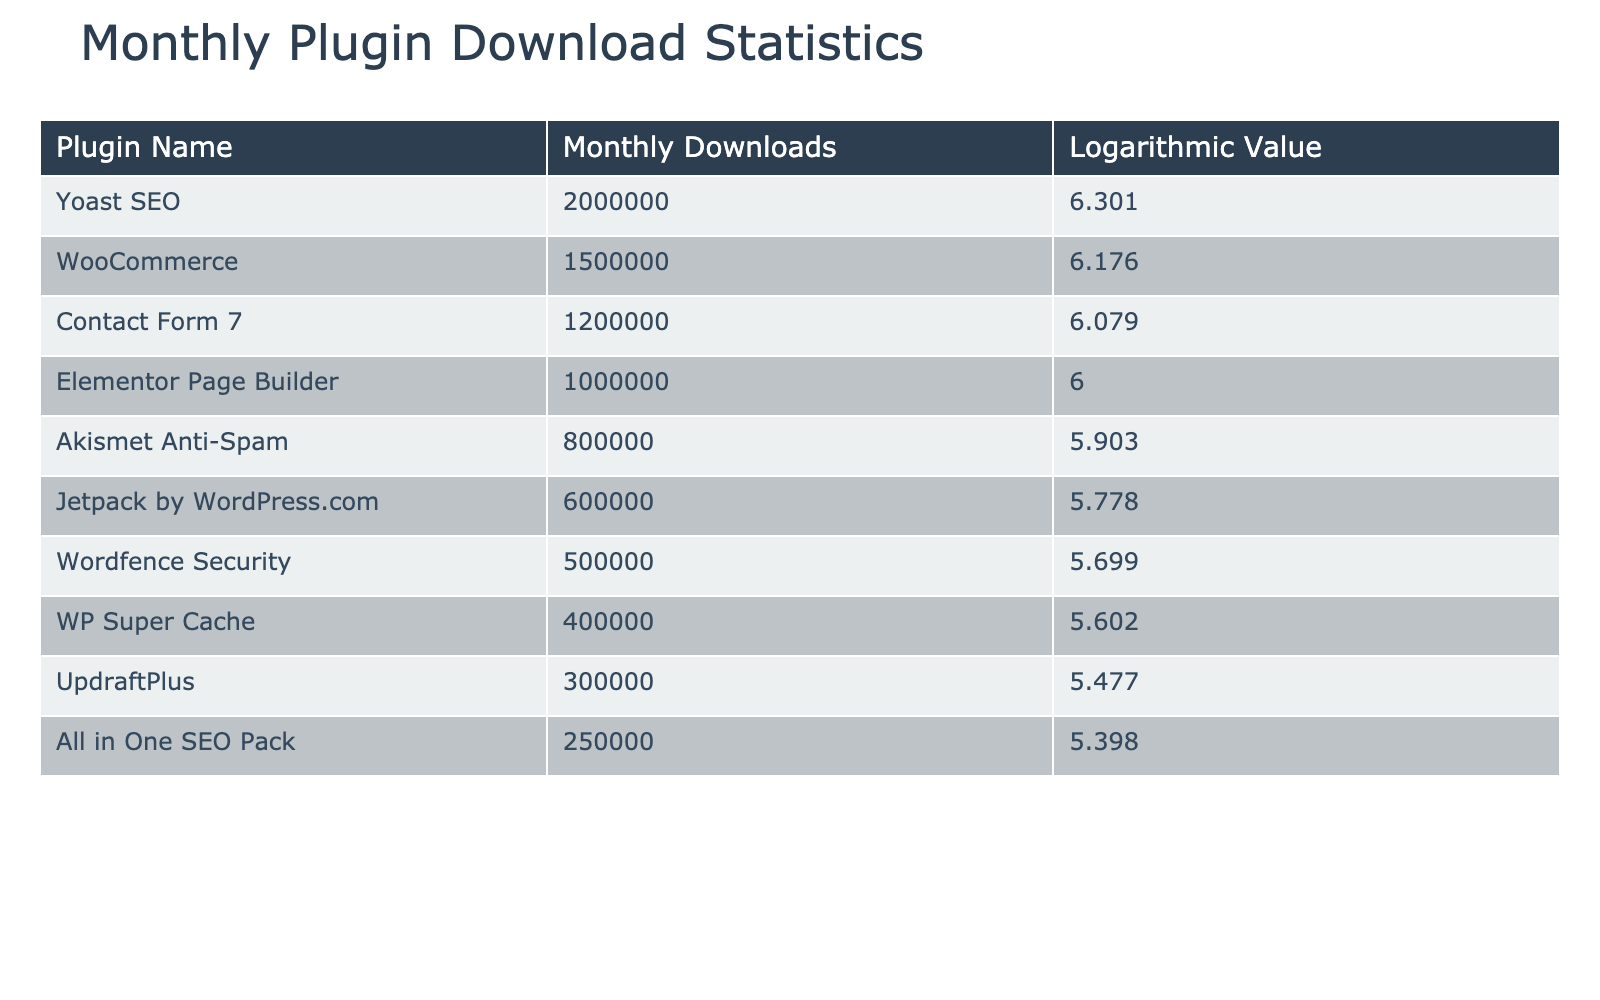What is the plugin with the highest number of monthly downloads? By examining the "Monthly Downloads" column, we can see that "Yoast SEO" has the highest value of 2,000,000.
Answer: Yoast SEO What is the logarithmic value associated with WooCommerce? Looking directly under the "Logarithmic Value" column for "WooCommerce," the value is 6.176.
Answer: 6.176 Is Elementor Page Builder more popular than Jetpack by WordPress.com in terms of monthly downloads? Checking the "Monthly Downloads" column, Elementor has 1,000,000 downloads while Jetpack has 600,000, indicating Elementor is more popular.
Answer: Yes What is the total number of monthly downloads for the top three plugins? The top three plugins are "Yoast SEO" (2,000,000), "WooCommerce" (1,500,000), and "Contact Form 7" (1,200,000). Adding these gives 2,000,000 + 1,500,000 + 1,200,000 = 4,700,000.
Answer: 4,700,000 What is the difference in logarithmic values between Akismet Anti-Spam and WP Super Cache? The logarithmic value for Akismet is 5.903 and for WP Super Cache, it is 5.602. The difference is 5.903 - 5.602 = 0.301.
Answer: 0.301 Which plugin has the lowest monthly downloads, and what is that number? In the "Monthly Downloads" column, "WP Super Cache" has the lowest number of downloads at 400,000.
Answer: WP Super Cache, 400,000 Is the logarithmic value of UpdraftPlus greater than that of All in One SEO Pack? The logarithmic value for UpdraftPlus is 5.477 and for All in One SEO Pack, it is 5.398. Since 5.477 is greater than 5.398, the statement is true.
Answer: Yes What is the average number of monthly downloads for the five least downloaded plugins? The five least downloaded plugins are Wordfence Security (500,000), WP Super Cache (400,000), UpdraftPlus (300,000), All in One SEO Pack (250,000), and Jetpack by WordPress.com (600,000). Their total is 500,000 + 400,000 + 300,000 + 250,000 + 600,000 = 2,050,000. The average is 2,050,000 / 5 = 410,000.
Answer: 410,000 What percentage of total downloads does Contact Form 7 contribute? First, calculate the total downloads: 2,000,000 + 1,500,000 + 1,200,000 + 1,000,000 + 800,000 + 600,000 + 500,000 + 400,000 + 300,000 + 250,000 = 8,650,000. The contribution from Contact Form 7 is 1,200,000. Therefore, the percentage is (1,200,000 / 8,650,000) * 100 = approximately 13.87%.
Answer: 13.87% 